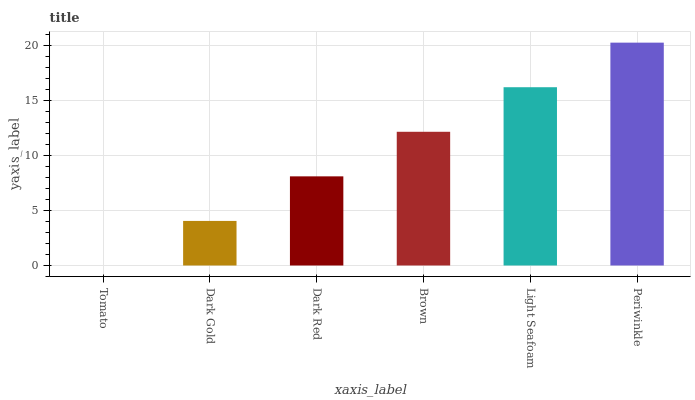Is Tomato the minimum?
Answer yes or no. Yes. Is Periwinkle the maximum?
Answer yes or no. Yes. Is Dark Gold the minimum?
Answer yes or no. No. Is Dark Gold the maximum?
Answer yes or no. No. Is Dark Gold greater than Tomato?
Answer yes or no. Yes. Is Tomato less than Dark Gold?
Answer yes or no. Yes. Is Tomato greater than Dark Gold?
Answer yes or no. No. Is Dark Gold less than Tomato?
Answer yes or no. No. Is Brown the high median?
Answer yes or no. Yes. Is Dark Red the low median?
Answer yes or no. Yes. Is Tomato the high median?
Answer yes or no. No. Is Brown the low median?
Answer yes or no. No. 